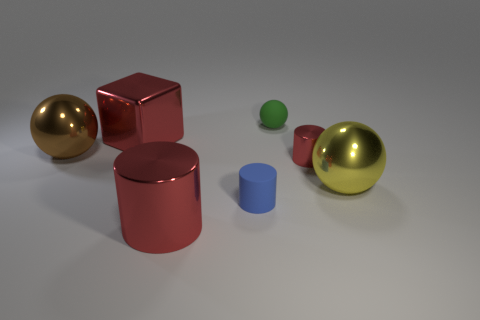Add 1 yellow rubber objects. How many objects exist? 8 Subtract all small cylinders. How many cylinders are left? 1 Subtract 0 gray balls. How many objects are left? 7 Subtract all cubes. How many objects are left? 6 Subtract 1 balls. How many balls are left? 2 Subtract all red cylinders. Subtract all red balls. How many cylinders are left? 1 Subtract all cyan balls. How many brown cylinders are left? 0 Subtract all large matte cylinders. Subtract all large metal cylinders. How many objects are left? 6 Add 3 large cubes. How many large cubes are left? 4 Add 5 big yellow metallic objects. How many big yellow metallic objects exist? 6 